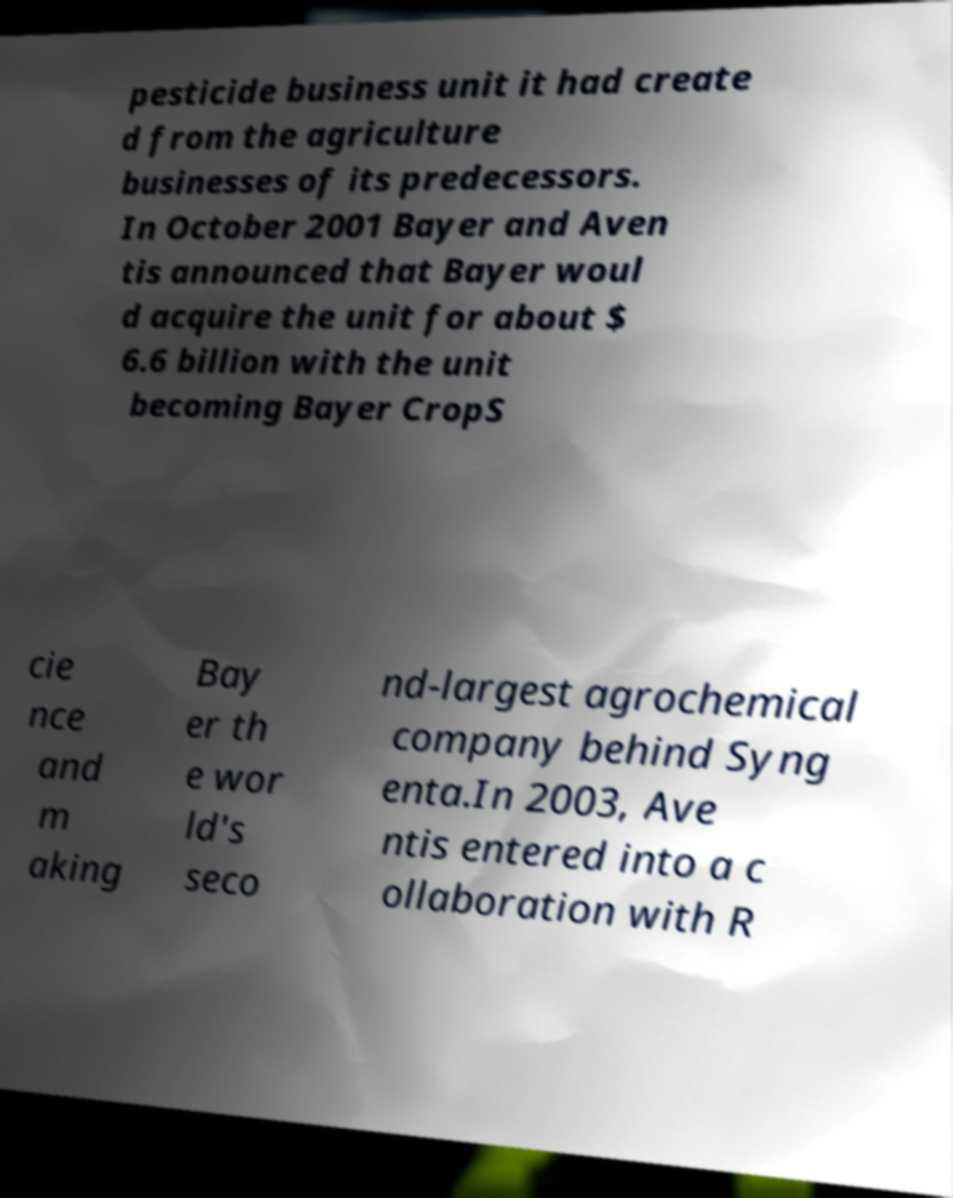I need the written content from this picture converted into text. Can you do that? pesticide business unit it had create d from the agriculture businesses of its predecessors. In October 2001 Bayer and Aven tis announced that Bayer woul d acquire the unit for about $ 6.6 billion with the unit becoming Bayer CropS cie nce and m aking Bay er th e wor ld's seco nd-largest agrochemical company behind Syng enta.In 2003, Ave ntis entered into a c ollaboration with R 